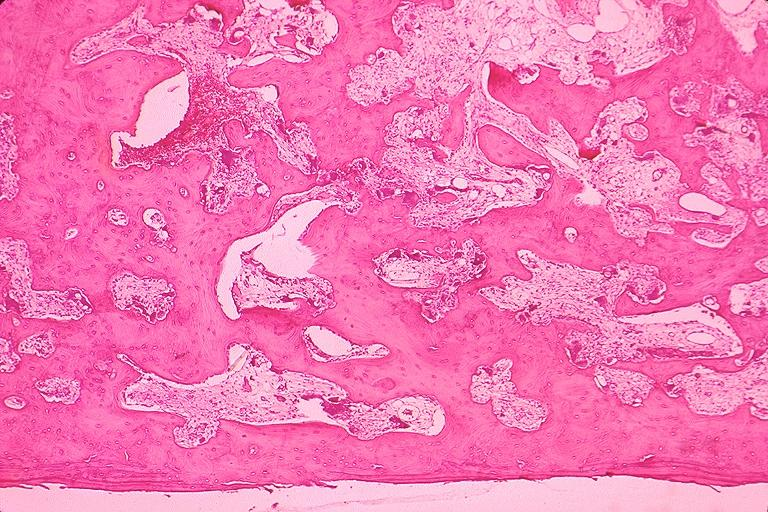what does this image show?
Answer the question using a single word or phrase. Pagets disease 